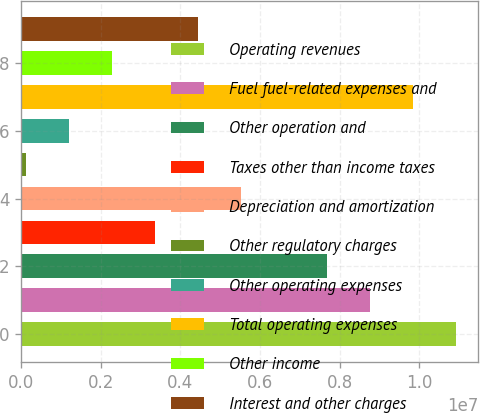Convert chart to OTSL. <chart><loc_0><loc_0><loc_500><loc_500><bar_chart><fcel>Operating revenues<fcel>Fuel fuel-related expenses and<fcel>Other operation and<fcel>Taxes other than income taxes<fcel>Depreciation and amortization<fcel>Other regulatory charges<fcel>Other operating expenses<fcel>Total operating expenses<fcel>Other income<fcel>Interest and other charges<nl><fcel>1.09322e+07<fcel>8.77026e+06<fcel>7.68931e+06<fcel>3.36552e+06<fcel>5.52742e+06<fcel>122680<fcel>1.20363e+06<fcel>9.85121e+06<fcel>2.28458e+06<fcel>4.44647e+06<nl></chart> 